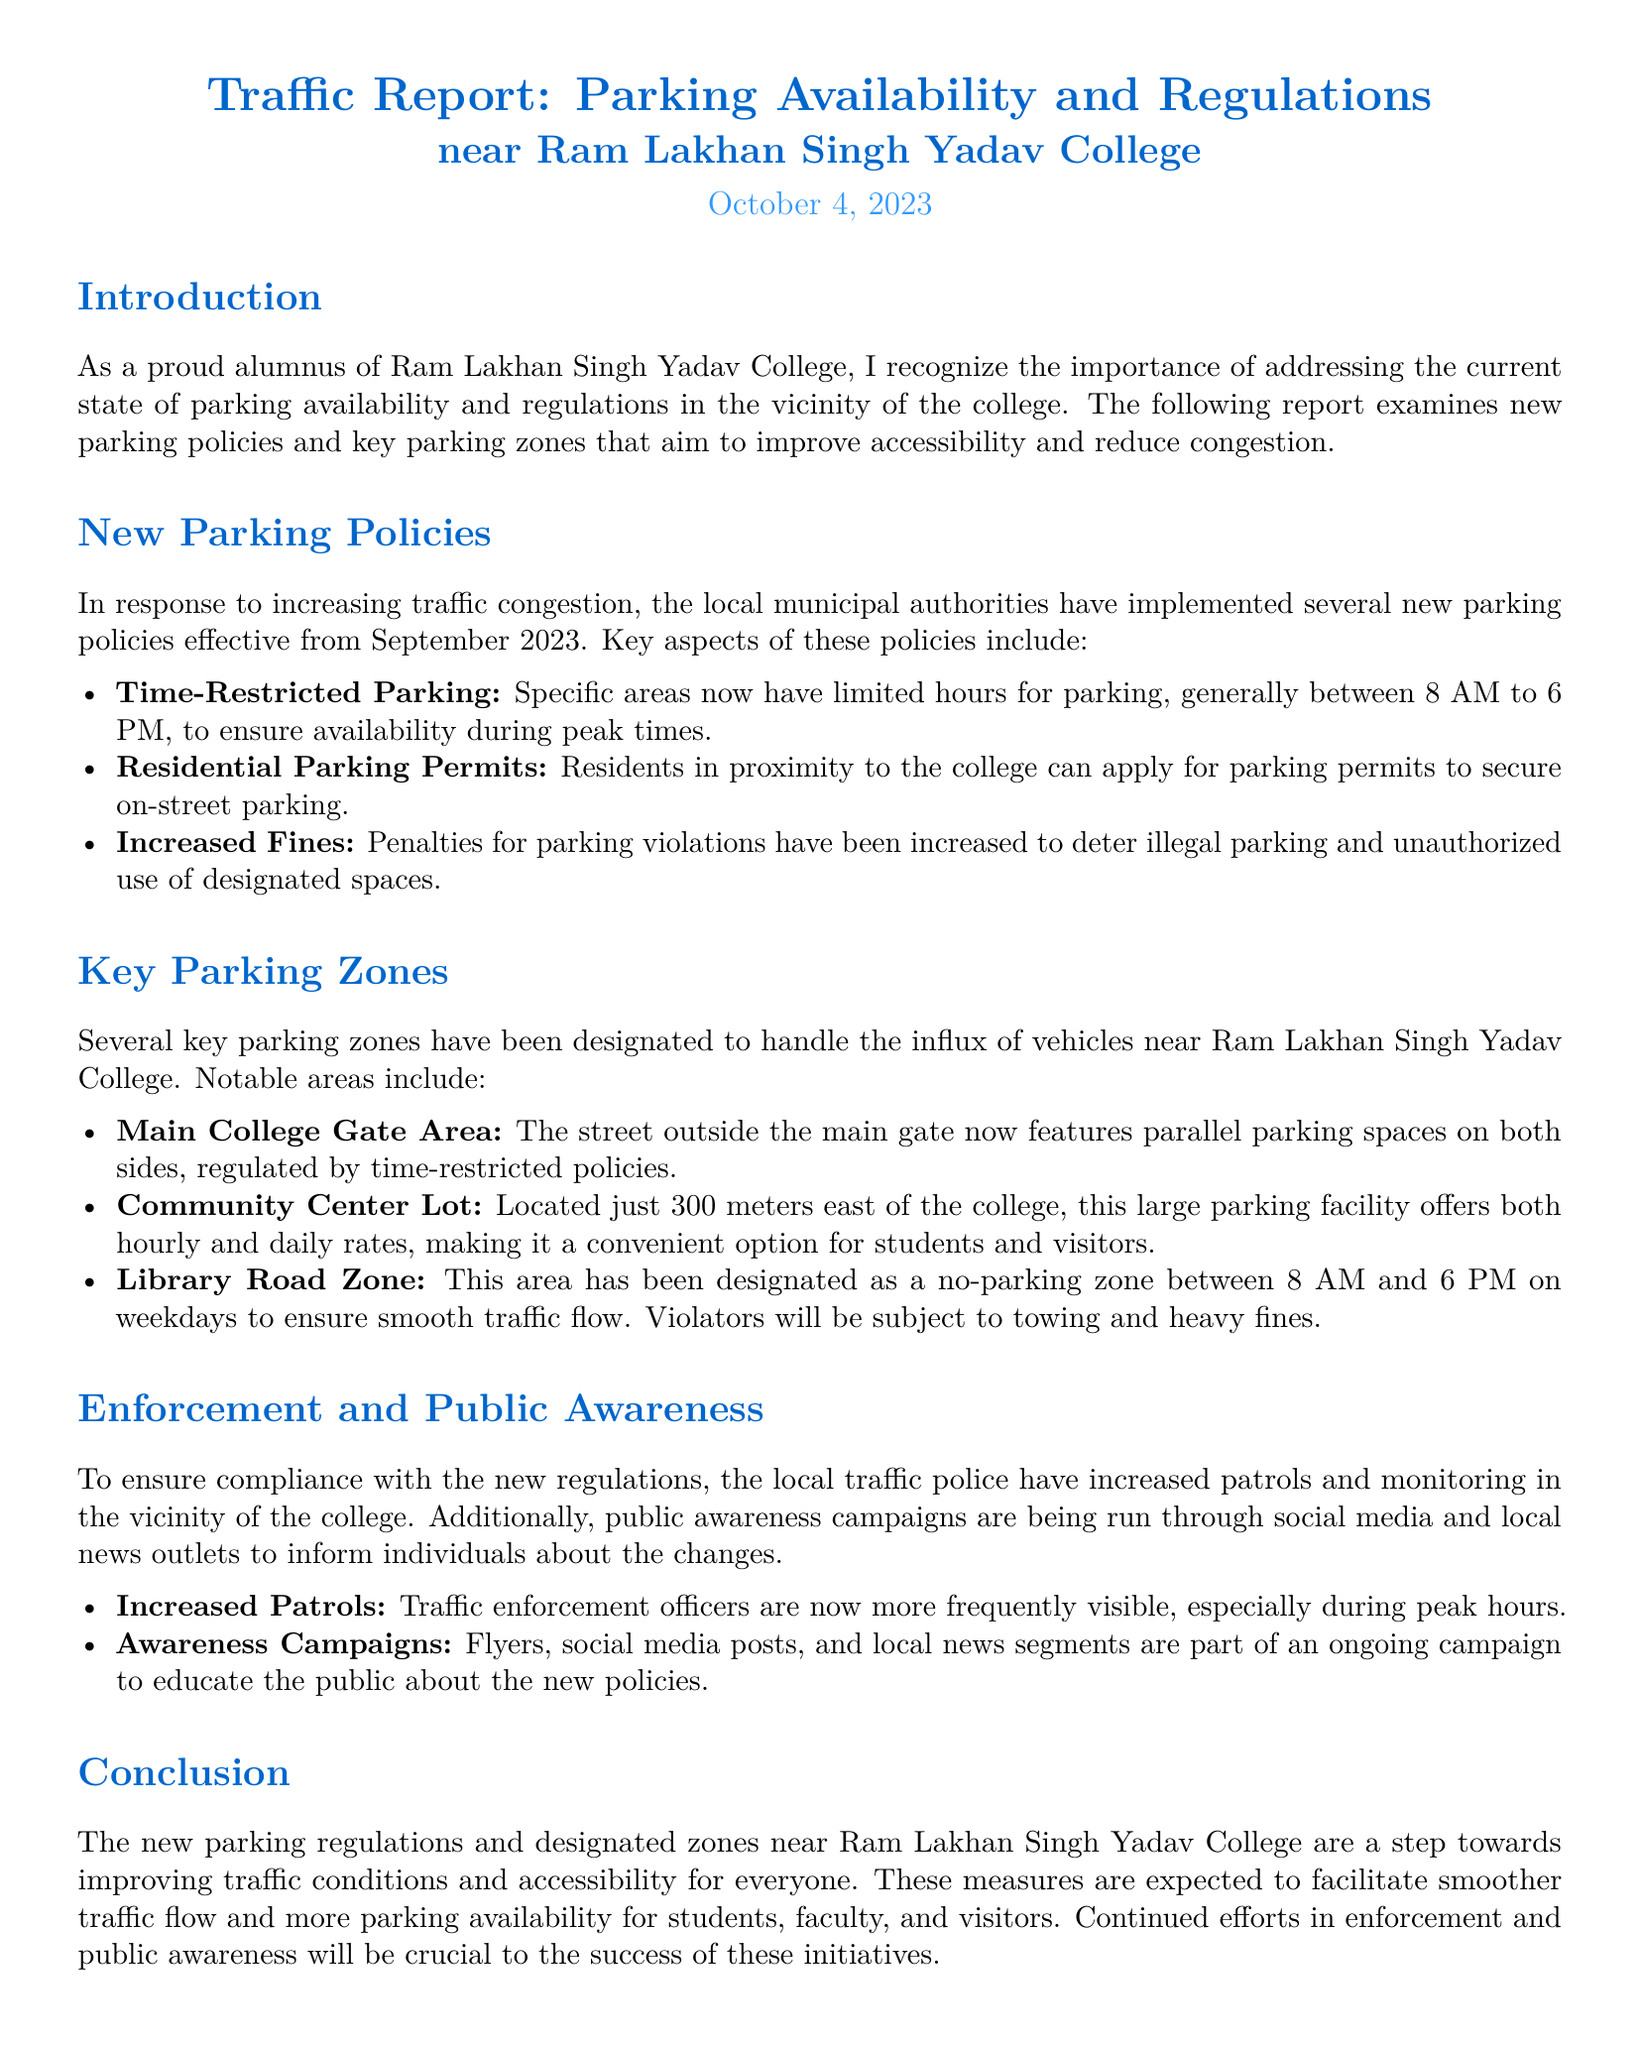What is the date of the report? The report is dated October 4, 2023.
Answer: October 4, 2023 What area features time-restricted parking? The report mentions that the Main College Gate Area has time-restricted parking policies.
Answer: Main College Gate Area What is the distance of the Community Center Lot from the college? The Community Center Lot is located just 300 meters east of the college.
Answer: 300 meters What time is the Library Road Zone designated as a no-parking zone? The no-parking hours for the Library Road Zone are between 8 AM and 6 PM on weekdays.
Answer: 8 AM to 6 PM What has increased to deter illegal parking? The penalties for parking violations have been increased.
Answer: Increased fines Why are the new parking policies implemented? The new parking policies were implemented in response to increasing traffic congestion.
Answer: Increasing traffic congestion What is the purpose of public awareness campaigns mentioned in the report? The campaigns aim to educate the public about the new policies.
Answer: Educate the public about the new policies How often are traffic enforcement officers now visible? Traffic enforcement officers are now more frequently visible, especially during peak hours.
Answer: More frequently visible What type of report is this document? This document is a Traffic Report focused on parking availability and regulations.
Answer: Traffic Report 